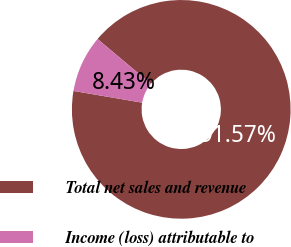Convert chart to OTSL. <chart><loc_0><loc_0><loc_500><loc_500><pie_chart><fcel>Total net sales and revenue<fcel>Income (loss) attributable to<nl><fcel>91.57%<fcel>8.43%<nl></chart> 